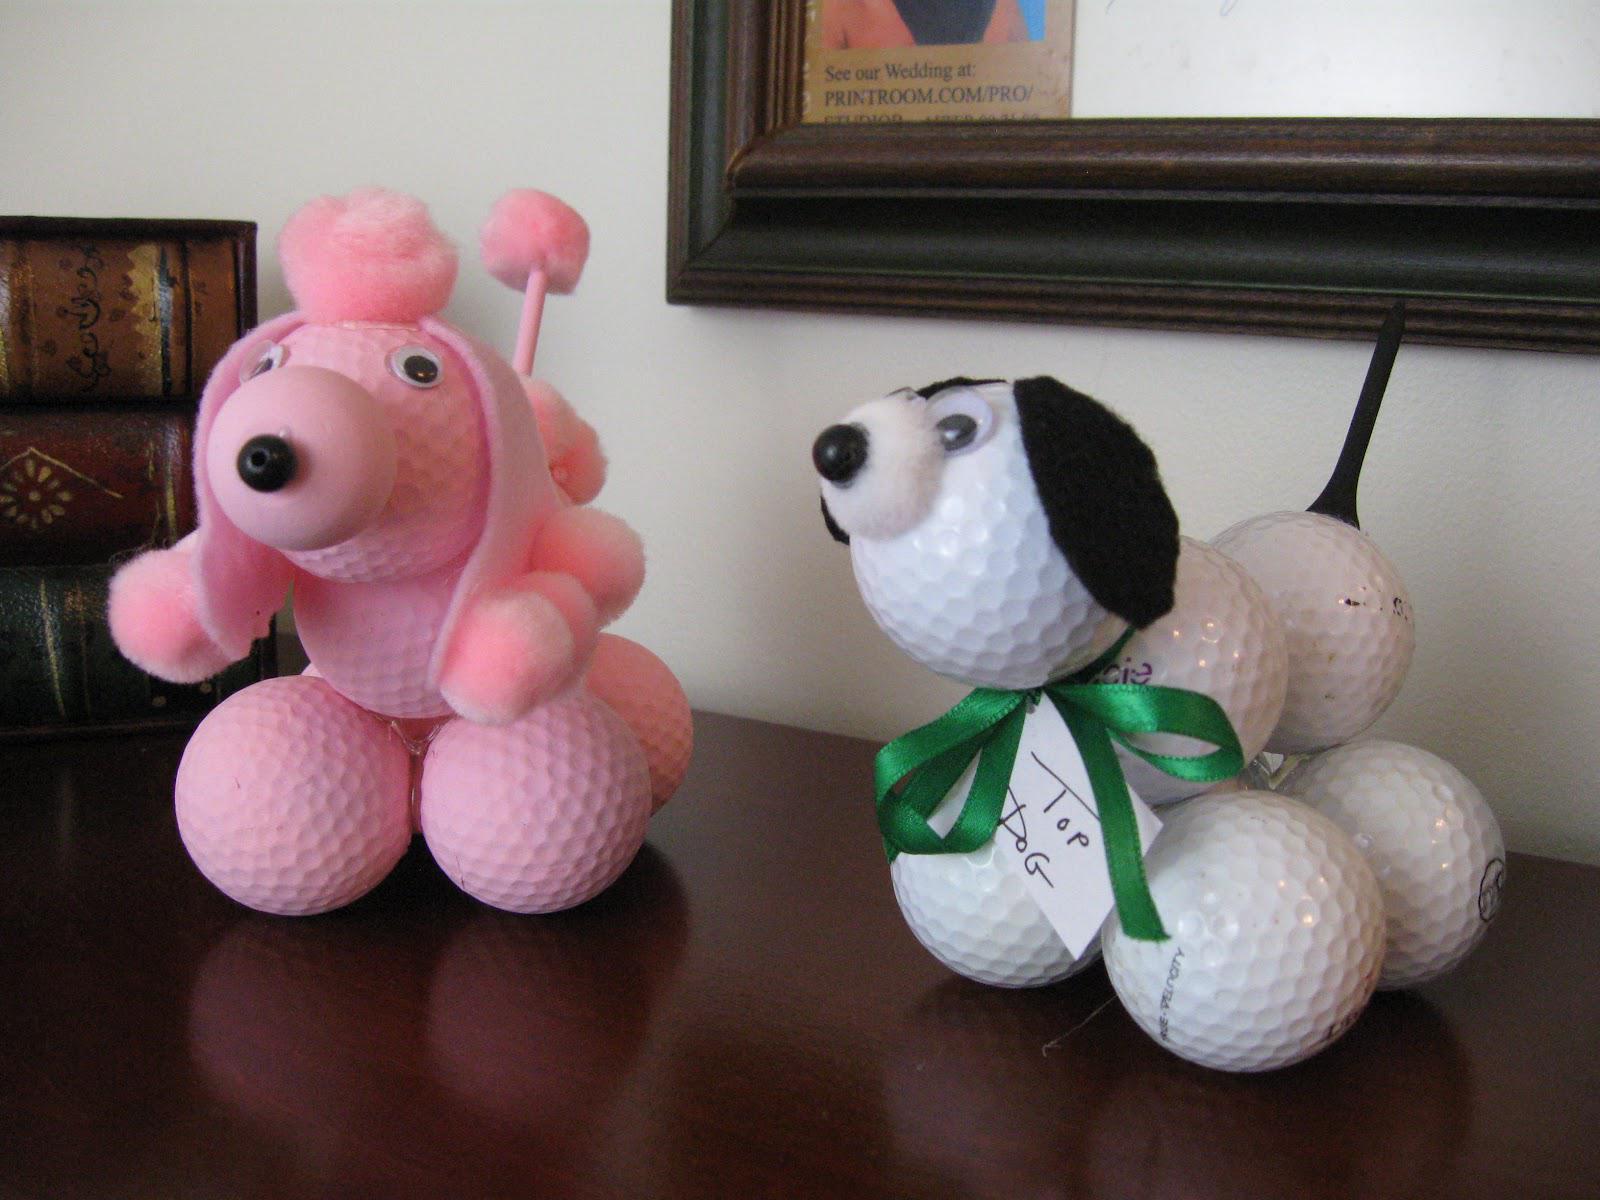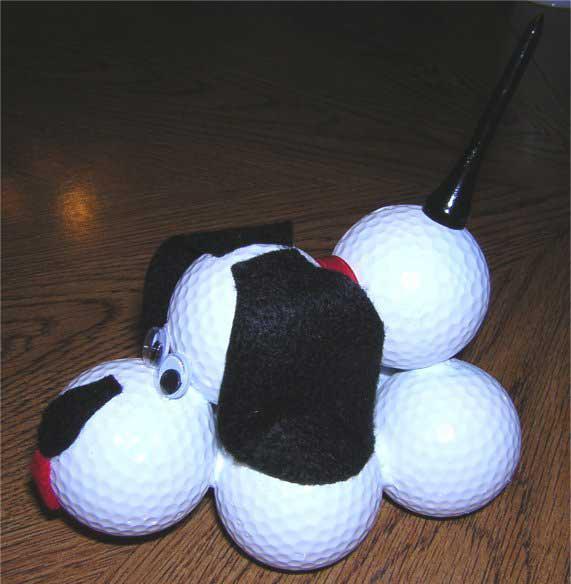The first image is the image on the left, the second image is the image on the right. Considering the images on both sides, is "All the golf balls are white." valid? Answer yes or no. No. The first image is the image on the left, the second image is the image on the right. For the images shown, is this caption "Each image includes a dog figure made out of white golf balls with a black tee tail." true? Answer yes or no. Yes. 